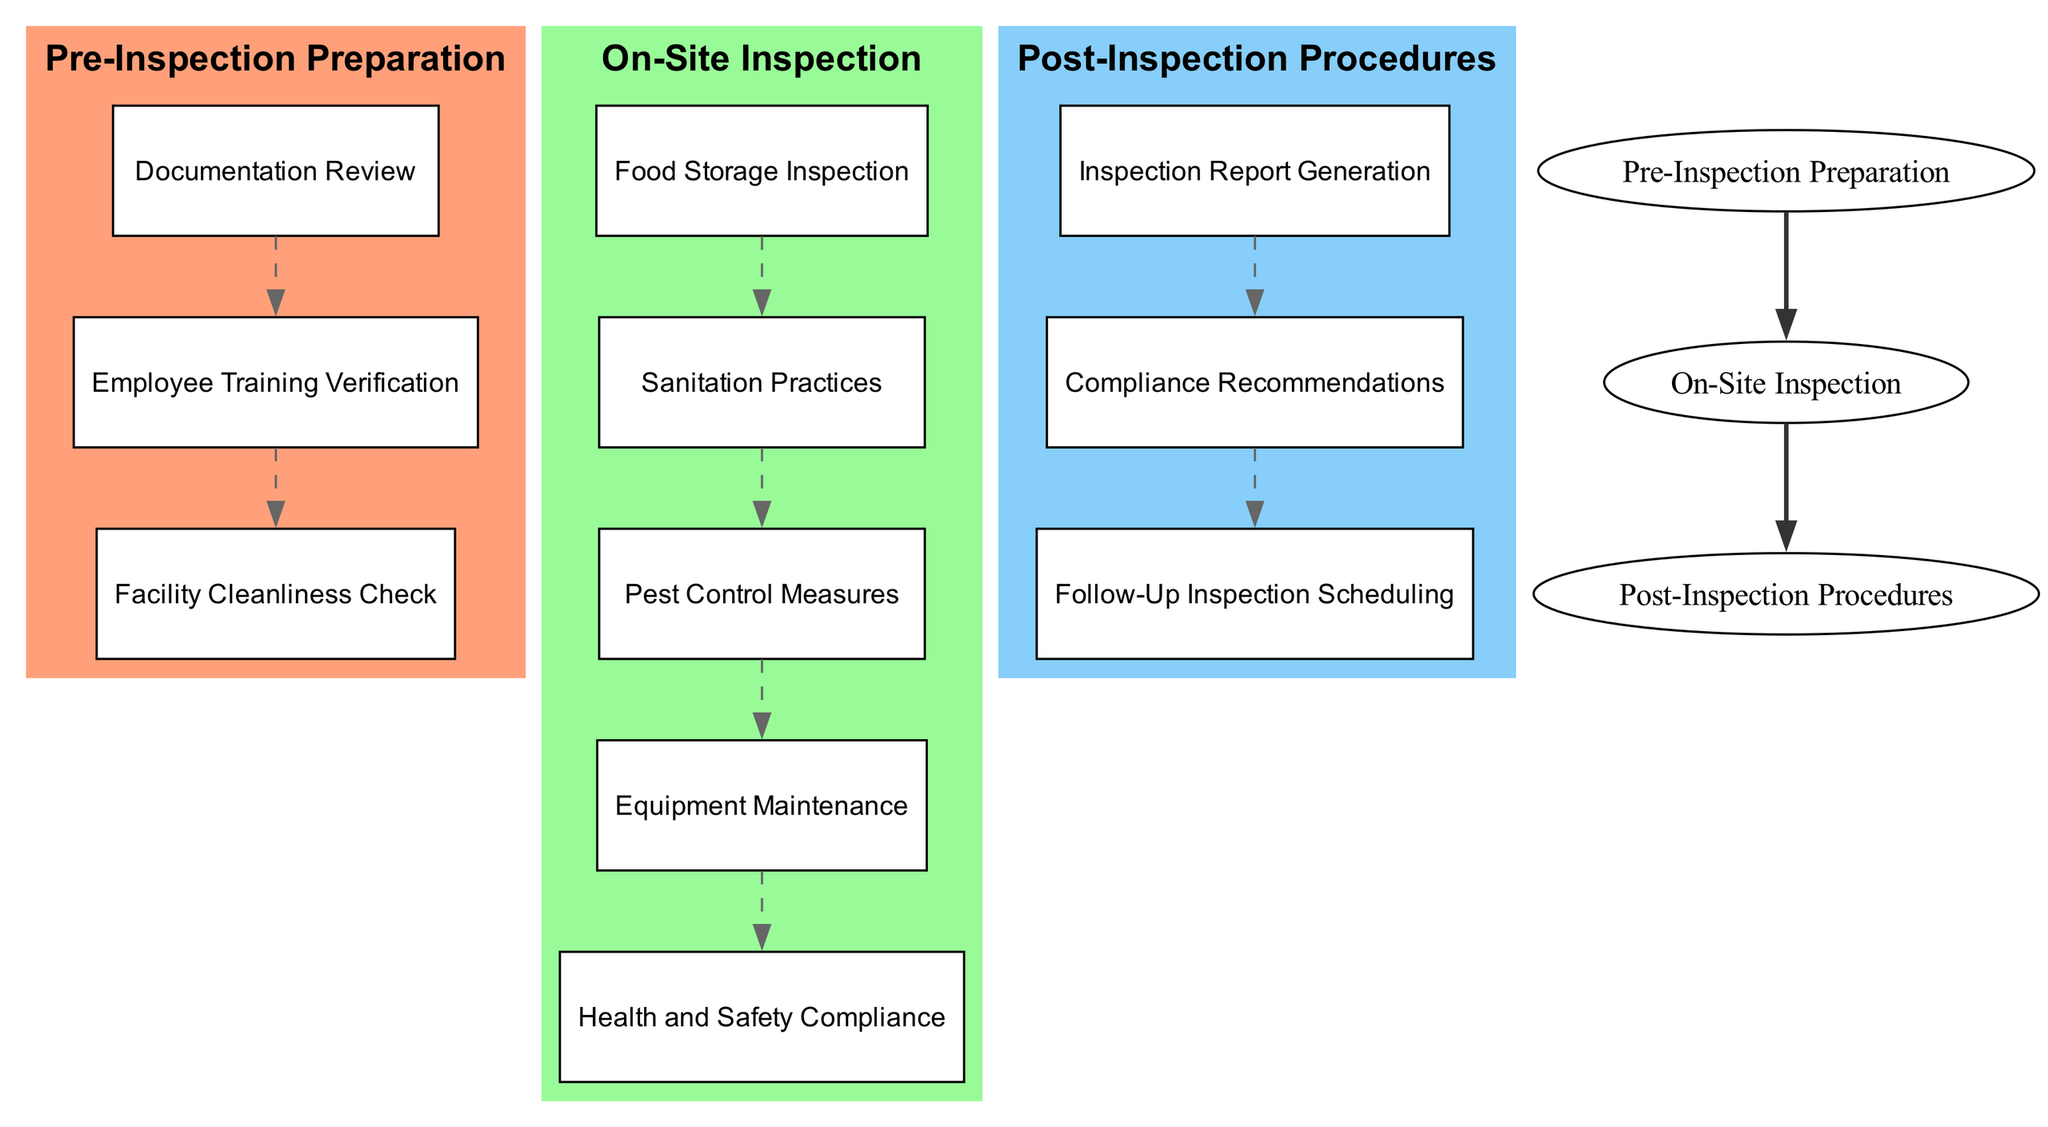What is the first step in the inspection process? The diagram shows that the first block is "Pre-Inspection Preparation," which contains initial activities before the actual inspection begins.
Answer: Pre-Inspection Preparation How many main blocks are there in the diagram? The diagram consists of three main blocks: "Pre-Inspection Preparation," "On-Site Inspection," and "Post-Inspection Procedures." Thus, the total count is three.
Answer: 3 What is the last step in the inspection process? The final block in the flow of the diagram is "Post-Inspection Procedures," which includes activities that occur after the inspection to address findings.
Answer: Post-Inspection Procedures Which element is checked for cleanliness during the On-Site Inspection? Within the "On-Site Inspection" block, the element focusing on cleanliness is "Sanitation Practices," which evaluates various areas for adherence to cleanliness standards.
Answer: Sanitation Practices What connects "On-Site Inspection" to "Post-Inspection Procedures"? The connection between "On-Site Inspection" and "Post-Inspection Procedures" is represented by a bold edge, indicating a direct flow from inspection activities to follow-up procedures.
Answer: Bold edge What type of records are reviewed in the Equipment Maintenance step? The "Equipment Maintenance" step involves reviewing maintenance records for kitchen equipment to ensure they are adequately maintained according to health regulations.
Answer: Maintenance records How many elements are included in the Pre-Inspection Preparation block? The "Pre-Inspection Preparation" block contains three specific elements: "Documentation Review," "Employee Training Verification," and "Facility Cleanliness Check." Therefore, the total number of elements is three.
Answer: 3 Which procedure involves scheduling follow-up visits? In the "Post-Inspection Procedures" block, the element that includes scheduling follow-up visits is "Follow-Up Inspection Scheduling." This ensures compliance issues identified during inspections are reviewed again.
Answer: Follow-Up Inspection Scheduling What is the purpose of Compliance Recommendations? "Compliance Recommendations" is aimed at providing guidance and corrective actions necessary to meet health and insurance compliance requirements after the inspection is completed.
Answer: Guidance on corrective actions What is one element that checks for pest issues during the On-Site Inspection? The diagram indicates that "Pest Control Measures" is an element within "On-Site Inspection" that specifically addresses checking for pest infestation and assessing control strategies.
Answer: Pest Control Measures 